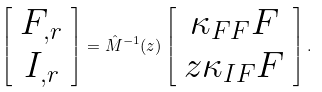<formula> <loc_0><loc_0><loc_500><loc_500>\left [ \begin{array} { c } F _ { , r } \\ I _ { , r } \end{array} \right ] = \hat { M } ^ { - 1 } ( z ) \left [ \begin{array} { c } \kappa _ { F F } F \\ z \kappa _ { I F } F \end{array} \right ] .</formula> 